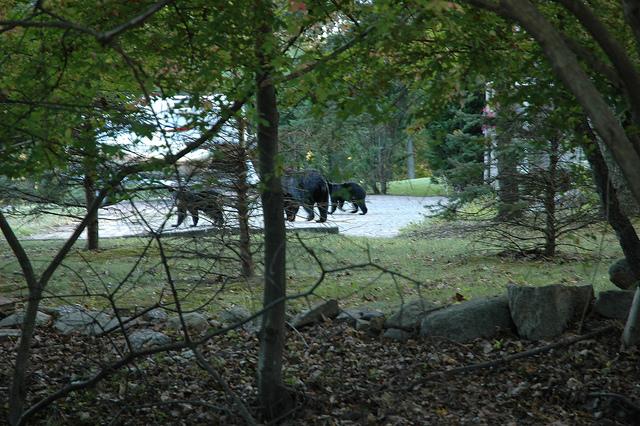Are there any humans in the picture?
Concise answer only. No. What animal is in the picture?
Be succinct. Bear. How many tree branches are there?
Short answer required. 25. How many bears are in this image?
Quick response, please. 3. Are the bears eating people?
Be succinct. No. 